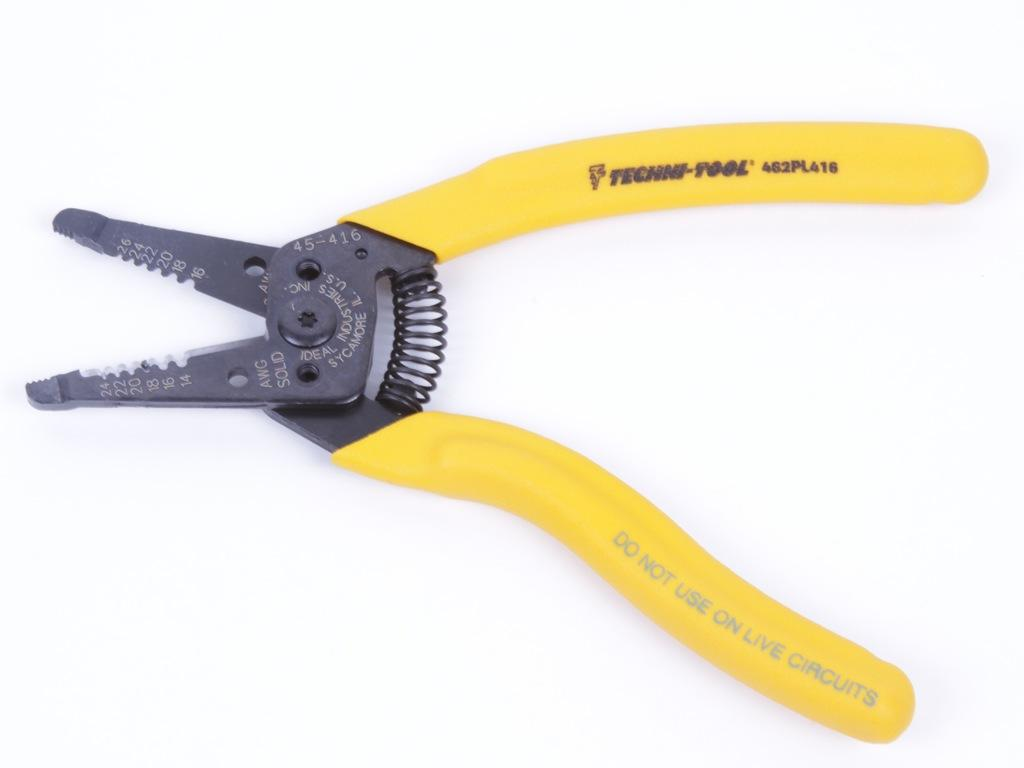Provide a one-sentence caption for the provided image. A yellow grip pliers tool with the writing Techni-Tool on one handle. 